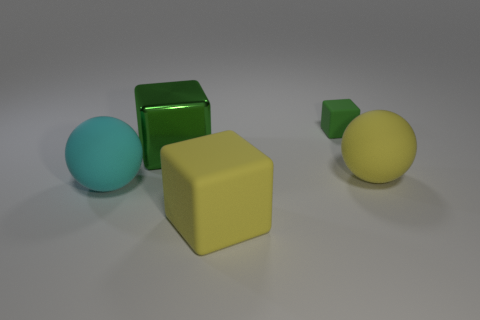There is a big matte object that is behind the big cyan rubber ball; does it have the same color as the rubber cube in front of the green rubber object?
Ensure brevity in your answer.  Yes. How many other cyan matte things are the same shape as the small object?
Your answer should be very brief. 0. There is a matte thing that is behind the large green cube; how many balls are left of it?
Your answer should be compact. 1. How many metallic things are either big brown cylinders or tiny things?
Your answer should be very brief. 0. Is there another large yellow cube made of the same material as the yellow block?
Offer a very short reply. No. How many things are either matte blocks in front of the big cyan matte sphere or matte blocks that are behind the cyan matte object?
Provide a succinct answer. 2. Does the cube in front of the metallic object have the same color as the big metallic block?
Offer a terse response. No. How many other things are the same color as the big metallic block?
Provide a short and direct response. 1. What material is the large green object?
Give a very brief answer. Metal. Is the size of the object on the left side of the green metal object the same as the yellow matte cube?
Offer a very short reply. Yes. 